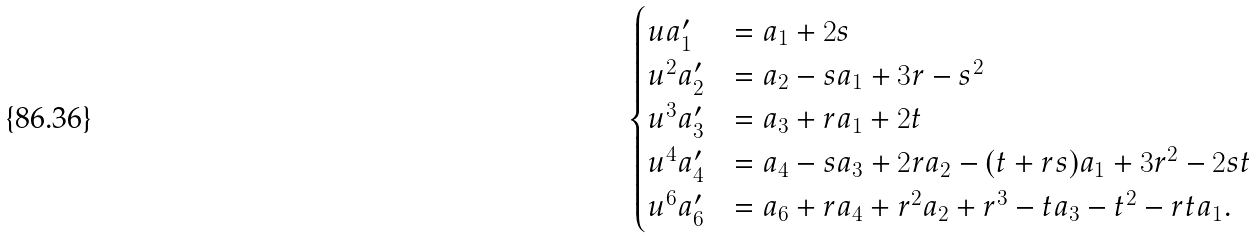Convert formula to latex. <formula><loc_0><loc_0><loc_500><loc_500>\begin{cases} u a ^ { \prime } _ { 1 } & = a _ { 1 } + 2 s \\ u ^ { 2 } a ^ { \prime } _ { 2 } & = a _ { 2 } - s a _ { 1 } + 3 r - s ^ { 2 } \\ u ^ { 3 } a ^ { \prime } _ { 3 } & = a _ { 3 } + r a _ { 1 } + 2 t \\ u ^ { 4 } a ^ { \prime } _ { 4 } & = a _ { 4 } - s a _ { 3 } + 2 r a _ { 2 } - ( t + r s ) a _ { 1 } + 3 r ^ { 2 } - 2 s t \\ u ^ { 6 } a ^ { \prime } _ { 6 } & = a _ { 6 } + r a _ { 4 } + r ^ { 2 } a _ { 2 } + r ^ { 3 } - t a _ { 3 } - t ^ { 2 } - r t a _ { 1 } . \end{cases}</formula> 